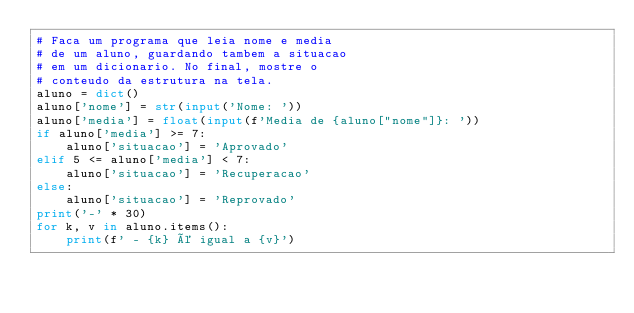<code> <loc_0><loc_0><loc_500><loc_500><_Python_># Faca um programa que leia nome e media
# de um aluno, guardando tambem a situacao
# em um dicionario. No final, mostre o
# conteudo da estrutura na tela.
aluno = dict()
aluno['nome'] = str(input('Nome: '))
aluno['media'] = float(input(f'Media de {aluno["nome"]}: '))
if aluno['media'] >= 7:
    aluno['situacao'] = 'Aprovado'
elif 5 <= aluno['media'] < 7:
    aluno['situacao'] = 'Recuperacao'
else:
    aluno['situacao'] = 'Reprovado'
print('-' * 30)
for k, v in aluno.items():
    print(f' - {k} é igual a {v}')</code> 